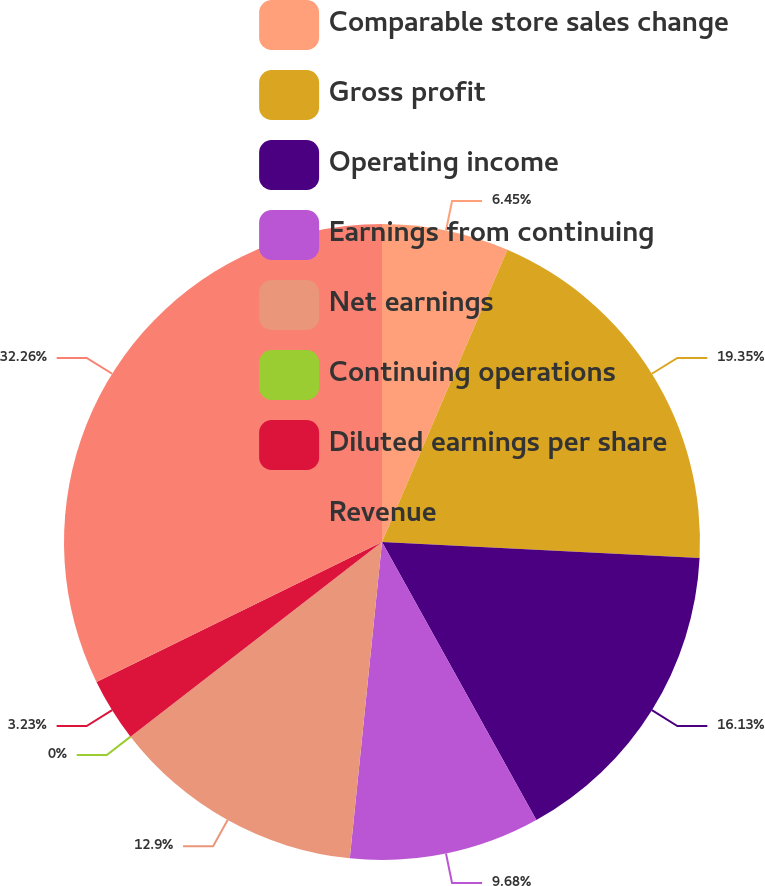Convert chart. <chart><loc_0><loc_0><loc_500><loc_500><pie_chart><fcel>Comparable store sales change<fcel>Gross profit<fcel>Operating income<fcel>Earnings from continuing<fcel>Net earnings<fcel>Continuing operations<fcel>Diluted earnings per share<fcel>Revenue<nl><fcel>6.45%<fcel>19.35%<fcel>16.13%<fcel>9.68%<fcel>12.9%<fcel>0.0%<fcel>3.23%<fcel>32.25%<nl></chart> 